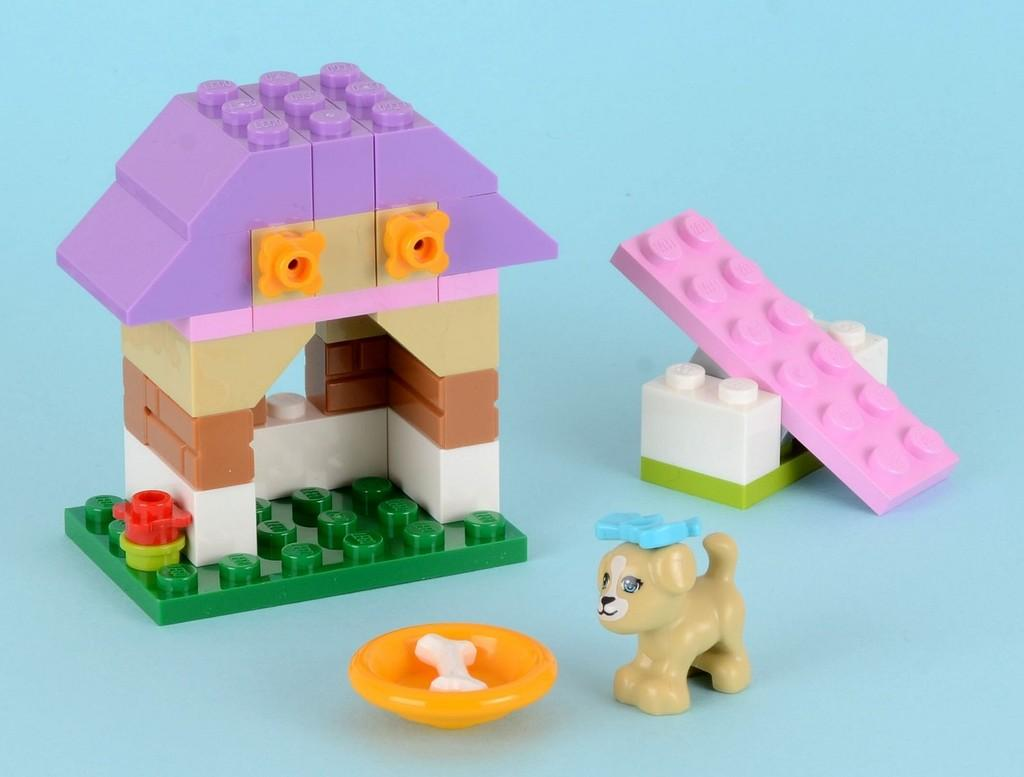What is the main structure in the image made of? There is a house made of Lego toys in the image. What is placed in front of the Lego house? There is a dog toy in front of the house. What is placed in front of the dog toy? There is a bone in front of the dog toy. How many trees are visible in the image? There are no trees visible in the image. What type of toothpaste is being used to clean the Lego house? There is no toothpaste present in the image, and the Lego house is not being cleaned. 